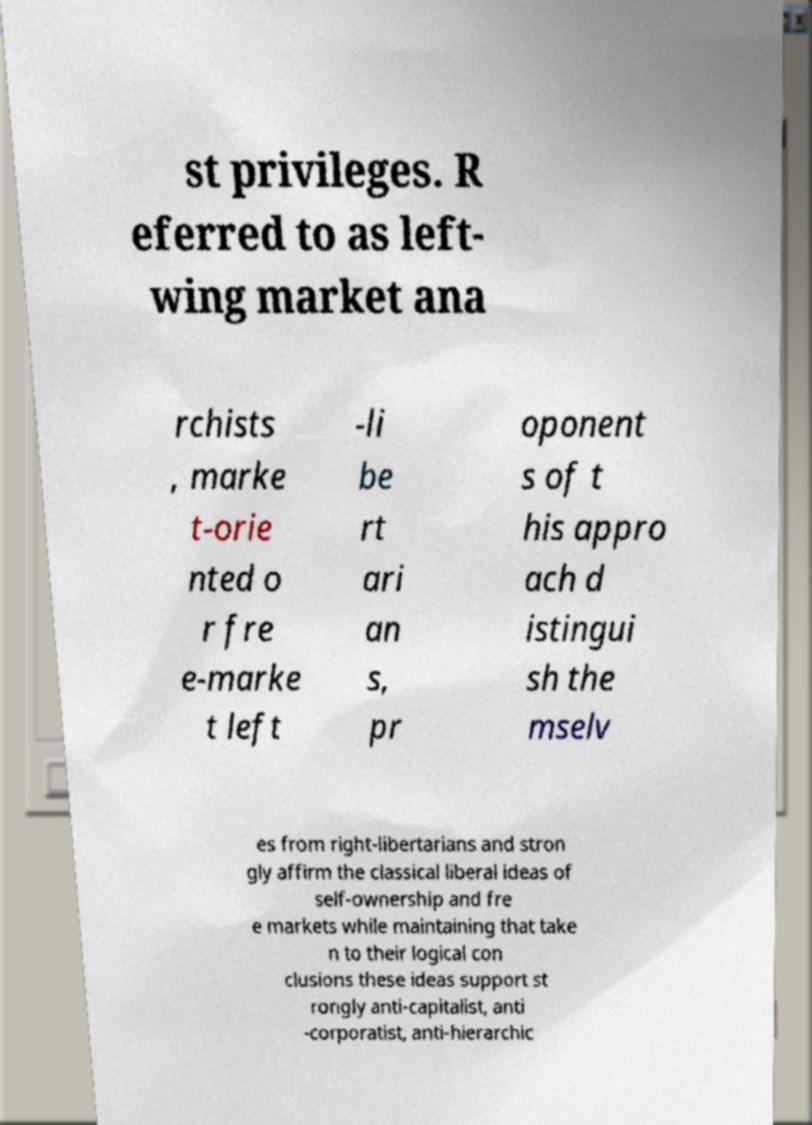Can you read and provide the text displayed in the image?This photo seems to have some interesting text. Can you extract and type it out for me? st privileges. R eferred to as left- wing market ana rchists , marke t-orie nted o r fre e-marke t left -li be rt ari an s, pr oponent s of t his appro ach d istingui sh the mselv es from right-libertarians and stron gly affirm the classical liberal ideas of self-ownership and fre e markets while maintaining that take n to their logical con clusions these ideas support st rongly anti-capitalist, anti -corporatist, anti-hierarchic 